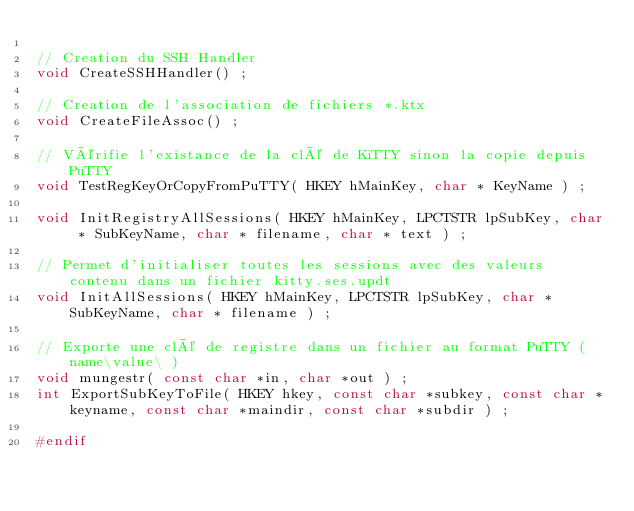<code> <loc_0><loc_0><loc_500><loc_500><_C_>
// Creation du SSH Handler
void CreateSSHHandler() ;

// Creation de l'association de fichiers *.ktx
void CreateFileAssoc() ;

// Vérifie l'existance de la clé de KiTTY sinon la copie depuis PuTTY
void TestRegKeyOrCopyFromPuTTY( HKEY hMainKey, char * KeyName ) ;

void InitRegistryAllSessions( HKEY hMainKey, LPCTSTR lpSubKey, char * SubKeyName, char * filename, char * text ) ;

// Permet d'initialiser toutes les sessions avec des valeurs contenu dans un fichier kitty.ses.updt
void InitAllSessions( HKEY hMainKey, LPCTSTR lpSubKey, char * SubKeyName, char * filename ) ;

// Exporte une clé de registre dans un fichier au format PuTTY (  name\value\ )
void mungestr( const char *in, char *out ) ;
int ExportSubKeyToFile( HKEY hkey, const char *subkey, const char *keyname, const char *maindir, const char *subdir ) ;

#endif
</code> 